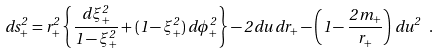Convert formula to latex. <formula><loc_0><loc_0><loc_500><loc_500>d s _ { + } ^ { 2 } = r _ { + } ^ { 2 } \left \{ \frac { d \xi _ { + } ^ { 2 } } { 1 - \xi _ { + } ^ { 2 } } + ( 1 - \xi _ { + } ^ { 2 } ) \, d \phi _ { + } ^ { 2 } \right \} - 2 \, d u \, d r _ { + } - \left ( 1 - \frac { 2 \, m _ { + } } { r _ { + } } \right ) \, d u ^ { 2 } \ .</formula> 